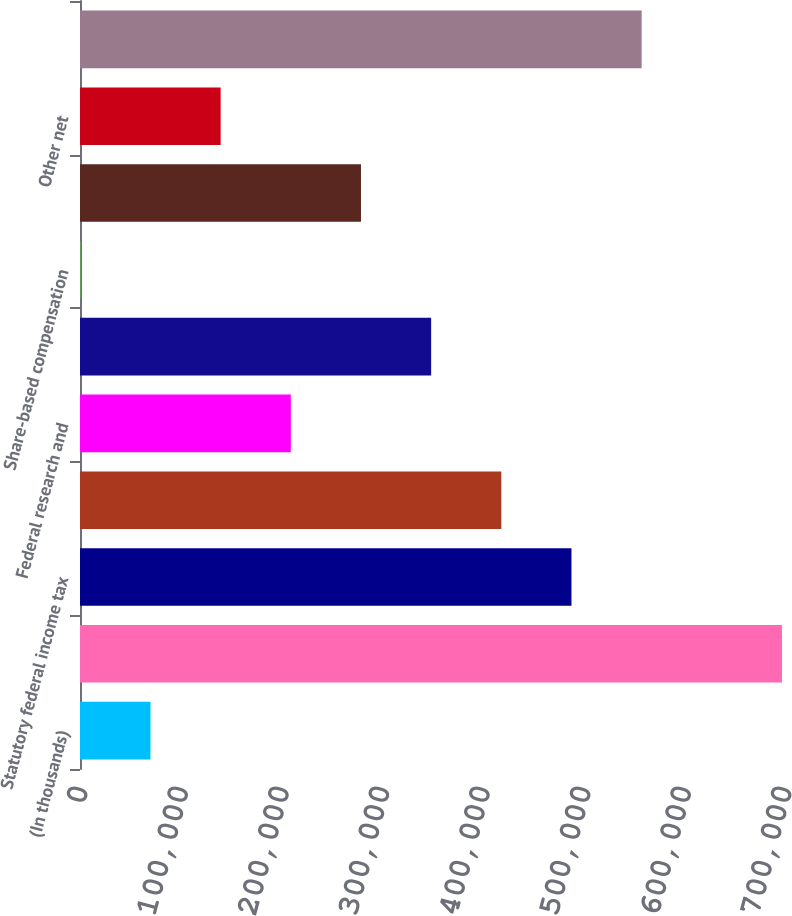Convert chart to OTSL. <chart><loc_0><loc_0><loc_500><loc_500><bar_chart><fcel>(In thousands)<fcel>Income from continuing<fcel>Statutory federal income tax<fcel>State income tax net of<fcel>Federal research and<fcel>Domestic production activities<fcel>Share-based compensation<fcel>Tax exempt interest<fcel>Other net<fcel>Total provision for income<nl><fcel>70078.4<fcel>697985<fcel>488683<fcel>418915<fcel>209613<fcel>349148<fcel>311<fcel>279381<fcel>139846<fcel>558450<nl></chart> 